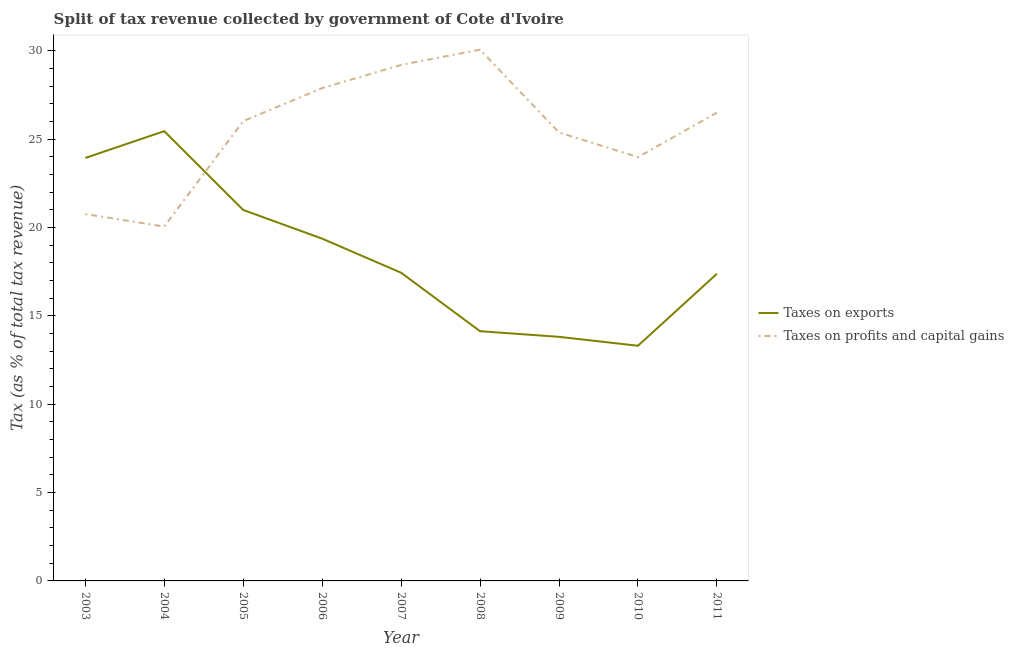Is the number of lines equal to the number of legend labels?
Ensure brevity in your answer.  Yes. What is the percentage of revenue obtained from taxes on exports in 2003?
Offer a terse response. 23.94. Across all years, what is the maximum percentage of revenue obtained from taxes on profits and capital gains?
Provide a succinct answer. 30.07. Across all years, what is the minimum percentage of revenue obtained from taxes on profits and capital gains?
Offer a very short reply. 20.06. In which year was the percentage of revenue obtained from taxes on exports minimum?
Provide a short and direct response. 2010. What is the total percentage of revenue obtained from taxes on exports in the graph?
Give a very brief answer. 165.85. What is the difference between the percentage of revenue obtained from taxes on exports in 2003 and that in 2010?
Offer a terse response. 10.63. What is the difference between the percentage of revenue obtained from taxes on profits and capital gains in 2005 and the percentage of revenue obtained from taxes on exports in 2010?
Make the answer very short. 12.71. What is the average percentage of revenue obtained from taxes on exports per year?
Your response must be concise. 18.43. In the year 2009, what is the difference between the percentage of revenue obtained from taxes on profits and capital gains and percentage of revenue obtained from taxes on exports?
Offer a terse response. 11.56. What is the ratio of the percentage of revenue obtained from taxes on profits and capital gains in 2005 to that in 2007?
Your answer should be very brief. 0.89. Is the difference between the percentage of revenue obtained from taxes on exports in 2005 and 2010 greater than the difference between the percentage of revenue obtained from taxes on profits and capital gains in 2005 and 2010?
Your answer should be very brief. Yes. What is the difference between the highest and the second highest percentage of revenue obtained from taxes on exports?
Make the answer very short. 1.52. What is the difference between the highest and the lowest percentage of revenue obtained from taxes on profits and capital gains?
Ensure brevity in your answer.  10.01. Is the sum of the percentage of revenue obtained from taxes on profits and capital gains in 2004 and 2011 greater than the maximum percentage of revenue obtained from taxes on exports across all years?
Your response must be concise. Yes. Does the percentage of revenue obtained from taxes on profits and capital gains monotonically increase over the years?
Provide a succinct answer. No. Is the percentage of revenue obtained from taxes on exports strictly greater than the percentage of revenue obtained from taxes on profits and capital gains over the years?
Ensure brevity in your answer.  No. How many years are there in the graph?
Your answer should be very brief. 9. Are the values on the major ticks of Y-axis written in scientific E-notation?
Provide a short and direct response. No. Does the graph contain any zero values?
Provide a succinct answer. No. Does the graph contain grids?
Give a very brief answer. No. Where does the legend appear in the graph?
Offer a terse response. Center right. How are the legend labels stacked?
Keep it short and to the point. Vertical. What is the title of the graph?
Your answer should be very brief. Split of tax revenue collected by government of Cote d'Ivoire. What is the label or title of the Y-axis?
Give a very brief answer. Tax (as % of total tax revenue). What is the Tax (as % of total tax revenue) of Taxes on exports in 2003?
Offer a very short reply. 23.94. What is the Tax (as % of total tax revenue) of Taxes on profits and capital gains in 2003?
Give a very brief answer. 20.76. What is the Tax (as % of total tax revenue) of Taxes on exports in 2004?
Keep it short and to the point. 25.46. What is the Tax (as % of total tax revenue) in Taxes on profits and capital gains in 2004?
Your response must be concise. 20.06. What is the Tax (as % of total tax revenue) in Taxes on exports in 2005?
Make the answer very short. 21. What is the Tax (as % of total tax revenue) in Taxes on profits and capital gains in 2005?
Offer a very short reply. 26.02. What is the Tax (as % of total tax revenue) of Taxes on exports in 2006?
Ensure brevity in your answer.  19.37. What is the Tax (as % of total tax revenue) of Taxes on profits and capital gains in 2006?
Give a very brief answer. 27.89. What is the Tax (as % of total tax revenue) of Taxes on exports in 2007?
Make the answer very short. 17.44. What is the Tax (as % of total tax revenue) of Taxes on profits and capital gains in 2007?
Make the answer very short. 29.21. What is the Tax (as % of total tax revenue) in Taxes on exports in 2008?
Provide a short and direct response. 14.13. What is the Tax (as % of total tax revenue) in Taxes on profits and capital gains in 2008?
Give a very brief answer. 30.07. What is the Tax (as % of total tax revenue) in Taxes on exports in 2009?
Offer a terse response. 13.81. What is the Tax (as % of total tax revenue) in Taxes on profits and capital gains in 2009?
Your answer should be very brief. 25.38. What is the Tax (as % of total tax revenue) in Taxes on exports in 2010?
Give a very brief answer. 13.31. What is the Tax (as % of total tax revenue) of Taxes on profits and capital gains in 2010?
Your response must be concise. 23.99. What is the Tax (as % of total tax revenue) of Taxes on exports in 2011?
Provide a short and direct response. 17.38. What is the Tax (as % of total tax revenue) of Taxes on profits and capital gains in 2011?
Make the answer very short. 26.5. Across all years, what is the maximum Tax (as % of total tax revenue) in Taxes on exports?
Give a very brief answer. 25.46. Across all years, what is the maximum Tax (as % of total tax revenue) of Taxes on profits and capital gains?
Give a very brief answer. 30.07. Across all years, what is the minimum Tax (as % of total tax revenue) of Taxes on exports?
Offer a terse response. 13.31. Across all years, what is the minimum Tax (as % of total tax revenue) in Taxes on profits and capital gains?
Your response must be concise. 20.06. What is the total Tax (as % of total tax revenue) of Taxes on exports in the graph?
Your response must be concise. 165.85. What is the total Tax (as % of total tax revenue) in Taxes on profits and capital gains in the graph?
Your answer should be compact. 229.88. What is the difference between the Tax (as % of total tax revenue) of Taxes on exports in 2003 and that in 2004?
Keep it short and to the point. -1.52. What is the difference between the Tax (as % of total tax revenue) of Taxes on profits and capital gains in 2003 and that in 2004?
Keep it short and to the point. 0.7. What is the difference between the Tax (as % of total tax revenue) in Taxes on exports in 2003 and that in 2005?
Provide a succinct answer. 2.94. What is the difference between the Tax (as % of total tax revenue) of Taxes on profits and capital gains in 2003 and that in 2005?
Provide a succinct answer. -5.26. What is the difference between the Tax (as % of total tax revenue) in Taxes on exports in 2003 and that in 2006?
Make the answer very short. 4.57. What is the difference between the Tax (as % of total tax revenue) of Taxes on profits and capital gains in 2003 and that in 2006?
Offer a terse response. -7.13. What is the difference between the Tax (as % of total tax revenue) in Taxes on exports in 2003 and that in 2007?
Make the answer very short. 6.5. What is the difference between the Tax (as % of total tax revenue) of Taxes on profits and capital gains in 2003 and that in 2007?
Your answer should be very brief. -8.44. What is the difference between the Tax (as % of total tax revenue) in Taxes on exports in 2003 and that in 2008?
Your answer should be very brief. 9.81. What is the difference between the Tax (as % of total tax revenue) in Taxes on profits and capital gains in 2003 and that in 2008?
Provide a succinct answer. -9.3. What is the difference between the Tax (as % of total tax revenue) of Taxes on exports in 2003 and that in 2009?
Provide a succinct answer. 10.12. What is the difference between the Tax (as % of total tax revenue) of Taxes on profits and capital gains in 2003 and that in 2009?
Your answer should be very brief. -4.62. What is the difference between the Tax (as % of total tax revenue) in Taxes on exports in 2003 and that in 2010?
Give a very brief answer. 10.63. What is the difference between the Tax (as % of total tax revenue) in Taxes on profits and capital gains in 2003 and that in 2010?
Make the answer very short. -3.22. What is the difference between the Tax (as % of total tax revenue) of Taxes on exports in 2003 and that in 2011?
Offer a very short reply. 6.56. What is the difference between the Tax (as % of total tax revenue) of Taxes on profits and capital gains in 2003 and that in 2011?
Offer a terse response. -5.74. What is the difference between the Tax (as % of total tax revenue) in Taxes on exports in 2004 and that in 2005?
Provide a short and direct response. 4.46. What is the difference between the Tax (as % of total tax revenue) of Taxes on profits and capital gains in 2004 and that in 2005?
Your answer should be compact. -5.96. What is the difference between the Tax (as % of total tax revenue) in Taxes on exports in 2004 and that in 2006?
Make the answer very short. 6.08. What is the difference between the Tax (as % of total tax revenue) in Taxes on profits and capital gains in 2004 and that in 2006?
Offer a very short reply. -7.83. What is the difference between the Tax (as % of total tax revenue) of Taxes on exports in 2004 and that in 2007?
Make the answer very short. 8.01. What is the difference between the Tax (as % of total tax revenue) of Taxes on profits and capital gains in 2004 and that in 2007?
Offer a very short reply. -9.15. What is the difference between the Tax (as % of total tax revenue) in Taxes on exports in 2004 and that in 2008?
Provide a succinct answer. 11.32. What is the difference between the Tax (as % of total tax revenue) of Taxes on profits and capital gains in 2004 and that in 2008?
Give a very brief answer. -10.01. What is the difference between the Tax (as % of total tax revenue) in Taxes on exports in 2004 and that in 2009?
Provide a short and direct response. 11.64. What is the difference between the Tax (as % of total tax revenue) in Taxes on profits and capital gains in 2004 and that in 2009?
Your response must be concise. -5.32. What is the difference between the Tax (as % of total tax revenue) of Taxes on exports in 2004 and that in 2010?
Your answer should be very brief. 12.15. What is the difference between the Tax (as % of total tax revenue) in Taxes on profits and capital gains in 2004 and that in 2010?
Give a very brief answer. -3.93. What is the difference between the Tax (as % of total tax revenue) in Taxes on exports in 2004 and that in 2011?
Ensure brevity in your answer.  8.07. What is the difference between the Tax (as % of total tax revenue) in Taxes on profits and capital gains in 2004 and that in 2011?
Give a very brief answer. -6.45. What is the difference between the Tax (as % of total tax revenue) of Taxes on exports in 2005 and that in 2006?
Offer a very short reply. 1.62. What is the difference between the Tax (as % of total tax revenue) in Taxes on profits and capital gains in 2005 and that in 2006?
Offer a very short reply. -1.87. What is the difference between the Tax (as % of total tax revenue) in Taxes on exports in 2005 and that in 2007?
Ensure brevity in your answer.  3.55. What is the difference between the Tax (as % of total tax revenue) in Taxes on profits and capital gains in 2005 and that in 2007?
Give a very brief answer. -3.18. What is the difference between the Tax (as % of total tax revenue) in Taxes on exports in 2005 and that in 2008?
Provide a succinct answer. 6.86. What is the difference between the Tax (as % of total tax revenue) in Taxes on profits and capital gains in 2005 and that in 2008?
Offer a very short reply. -4.04. What is the difference between the Tax (as % of total tax revenue) of Taxes on exports in 2005 and that in 2009?
Ensure brevity in your answer.  7.18. What is the difference between the Tax (as % of total tax revenue) in Taxes on profits and capital gains in 2005 and that in 2009?
Your answer should be compact. 0.64. What is the difference between the Tax (as % of total tax revenue) of Taxes on exports in 2005 and that in 2010?
Make the answer very short. 7.69. What is the difference between the Tax (as % of total tax revenue) of Taxes on profits and capital gains in 2005 and that in 2010?
Provide a succinct answer. 2.04. What is the difference between the Tax (as % of total tax revenue) in Taxes on exports in 2005 and that in 2011?
Offer a very short reply. 3.61. What is the difference between the Tax (as % of total tax revenue) of Taxes on profits and capital gains in 2005 and that in 2011?
Your answer should be compact. -0.48. What is the difference between the Tax (as % of total tax revenue) in Taxes on exports in 2006 and that in 2007?
Your answer should be very brief. 1.93. What is the difference between the Tax (as % of total tax revenue) of Taxes on profits and capital gains in 2006 and that in 2007?
Provide a succinct answer. -1.31. What is the difference between the Tax (as % of total tax revenue) of Taxes on exports in 2006 and that in 2008?
Offer a very short reply. 5.24. What is the difference between the Tax (as % of total tax revenue) in Taxes on profits and capital gains in 2006 and that in 2008?
Your answer should be very brief. -2.18. What is the difference between the Tax (as % of total tax revenue) of Taxes on exports in 2006 and that in 2009?
Keep it short and to the point. 5.56. What is the difference between the Tax (as % of total tax revenue) in Taxes on profits and capital gains in 2006 and that in 2009?
Your response must be concise. 2.51. What is the difference between the Tax (as % of total tax revenue) in Taxes on exports in 2006 and that in 2010?
Offer a very short reply. 6.06. What is the difference between the Tax (as % of total tax revenue) in Taxes on profits and capital gains in 2006 and that in 2010?
Your answer should be compact. 3.91. What is the difference between the Tax (as % of total tax revenue) in Taxes on exports in 2006 and that in 2011?
Ensure brevity in your answer.  1.99. What is the difference between the Tax (as % of total tax revenue) in Taxes on profits and capital gains in 2006 and that in 2011?
Offer a terse response. 1.39. What is the difference between the Tax (as % of total tax revenue) in Taxes on exports in 2007 and that in 2008?
Keep it short and to the point. 3.31. What is the difference between the Tax (as % of total tax revenue) of Taxes on profits and capital gains in 2007 and that in 2008?
Your answer should be compact. -0.86. What is the difference between the Tax (as % of total tax revenue) in Taxes on exports in 2007 and that in 2009?
Your answer should be compact. 3.63. What is the difference between the Tax (as % of total tax revenue) in Taxes on profits and capital gains in 2007 and that in 2009?
Provide a succinct answer. 3.83. What is the difference between the Tax (as % of total tax revenue) in Taxes on exports in 2007 and that in 2010?
Your response must be concise. 4.13. What is the difference between the Tax (as % of total tax revenue) in Taxes on profits and capital gains in 2007 and that in 2010?
Offer a very short reply. 5.22. What is the difference between the Tax (as % of total tax revenue) of Taxes on exports in 2007 and that in 2011?
Make the answer very short. 0.06. What is the difference between the Tax (as % of total tax revenue) of Taxes on profits and capital gains in 2007 and that in 2011?
Ensure brevity in your answer.  2.7. What is the difference between the Tax (as % of total tax revenue) in Taxes on exports in 2008 and that in 2009?
Offer a terse response. 0.32. What is the difference between the Tax (as % of total tax revenue) of Taxes on profits and capital gains in 2008 and that in 2009?
Offer a very short reply. 4.69. What is the difference between the Tax (as % of total tax revenue) of Taxes on exports in 2008 and that in 2010?
Provide a succinct answer. 0.82. What is the difference between the Tax (as % of total tax revenue) in Taxes on profits and capital gains in 2008 and that in 2010?
Give a very brief answer. 6.08. What is the difference between the Tax (as % of total tax revenue) in Taxes on exports in 2008 and that in 2011?
Keep it short and to the point. -3.25. What is the difference between the Tax (as % of total tax revenue) in Taxes on profits and capital gains in 2008 and that in 2011?
Offer a terse response. 3.56. What is the difference between the Tax (as % of total tax revenue) of Taxes on exports in 2009 and that in 2010?
Provide a short and direct response. 0.5. What is the difference between the Tax (as % of total tax revenue) in Taxes on profits and capital gains in 2009 and that in 2010?
Make the answer very short. 1.39. What is the difference between the Tax (as % of total tax revenue) in Taxes on exports in 2009 and that in 2011?
Provide a succinct answer. -3.57. What is the difference between the Tax (as % of total tax revenue) of Taxes on profits and capital gains in 2009 and that in 2011?
Ensure brevity in your answer.  -1.12. What is the difference between the Tax (as % of total tax revenue) of Taxes on exports in 2010 and that in 2011?
Ensure brevity in your answer.  -4.07. What is the difference between the Tax (as % of total tax revenue) of Taxes on profits and capital gains in 2010 and that in 2011?
Keep it short and to the point. -2.52. What is the difference between the Tax (as % of total tax revenue) of Taxes on exports in 2003 and the Tax (as % of total tax revenue) of Taxes on profits and capital gains in 2004?
Offer a very short reply. 3.88. What is the difference between the Tax (as % of total tax revenue) in Taxes on exports in 2003 and the Tax (as % of total tax revenue) in Taxes on profits and capital gains in 2005?
Give a very brief answer. -2.08. What is the difference between the Tax (as % of total tax revenue) in Taxes on exports in 2003 and the Tax (as % of total tax revenue) in Taxes on profits and capital gains in 2006?
Your response must be concise. -3.95. What is the difference between the Tax (as % of total tax revenue) of Taxes on exports in 2003 and the Tax (as % of total tax revenue) of Taxes on profits and capital gains in 2007?
Provide a succinct answer. -5.27. What is the difference between the Tax (as % of total tax revenue) of Taxes on exports in 2003 and the Tax (as % of total tax revenue) of Taxes on profits and capital gains in 2008?
Provide a succinct answer. -6.13. What is the difference between the Tax (as % of total tax revenue) of Taxes on exports in 2003 and the Tax (as % of total tax revenue) of Taxes on profits and capital gains in 2009?
Make the answer very short. -1.44. What is the difference between the Tax (as % of total tax revenue) of Taxes on exports in 2003 and the Tax (as % of total tax revenue) of Taxes on profits and capital gains in 2010?
Provide a succinct answer. -0.05. What is the difference between the Tax (as % of total tax revenue) in Taxes on exports in 2003 and the Tax (as % of total tax revenue) in Taxes on profits and capital gains in 2011?
Your answer should be compact. -2.56. What is the difference between the Tax (as % of total tax revenue) in Taxes on exports in 2004 and the Tax (as % of total tax revenue) in Taxes on profits and capital gains in 2005?
Your answer should be very brief. -0.57. What is the difference between the Tax (as % of total tax revenue) in Taxes on exports in 2004 and the Tax (as % of total tax revenue) in Taxes on profits and capital gains in 2006?
Provide a succinct answer. -2.44. What is the difference between the Tax (as % of total tax revenue) of Taxes on exports in 2004 and the Tax (as % of total tax revenue) of Taxes on profits and capital gains in 2007?
Provide a short and direct response. -3.75. What is the difference between the Tax (as % of total tax revenue) in Taxes on exports in 2004 and the Tax (as % of total tax revenue) in Taxes on profits and capital gains in 2008?
Offer a very short reply. -4.61. What is the difference between the Tax (as % of total tax revenue) in Taxes on exports in 2004 and the Tax (as % of total tax revenue) in Taxes on profits and capital gains in 2009?
Your answer should be compact. 0.08. What is the difference between the Tax (as % of total tax revenue) in Taxes on exports in 2004 and the Tax (as % of total tax revenue) in Taxes on profits and capital gains in 2010?
Give a very brief answer. 1.47. What is the difference between the Tax (as % of total tax revenue) in Taxes on exports in 2004 and the Tax (as % of total tax revenue) in Taxes on profits and capital gains in 2011?
Offer a very short reply. -1.05. What is the difference between the Tax (as % of total tax revenue) in Taxes on exports in 2005 and the Tax (as % of total tax revenue) in Taxes on profits and capital gains in 2006?
Your response must be concise. -6.9. What is the difference between the Tax (as % of total tax revenue) in Taxes on exports in 2005 and the Tax (as % of total tax revenue) in Taxes on profits and capital gains in 2007?
Offer a terse response. -8.21. What is the difference between the Tax (as % of total tax revenue) in Taxes on exports in 2005 and the Tax (as % of total tax revenue) in Taxes on profits and capital gains in 2008?
Your answer should be very brief. -9.07. What is the difference between the Tax (as % of total tax revenue) in Taxes on exports in 2005 and the Tax (as % of total tax revenue) in Taxes on profits and capital gains in 2009?
Ensure brevity in your answer.  -4.38. What is the difference between the Tax (as % of total tax revenue) of Taxes on exports in 2005 and the Tax (as % of total tax revenue) of Taxes on profits and capital gains in 2010?
Your answer should be compact. -2.99. What is the difference between the Tax (as % of total tax revenue) of Taxes on exports in 2005 and the Tax (as % of total tax revenue) of Taxes on profits and capital gains in 2011?
Offer a very short reply. -5.51. What is the difference between the Tax (as % of total tax revenue) of Taxes on exports in 2006 and the Tax (as % of total tax revenue) of Taxes on profits and capital gains in 2007?
Make the answer very short. -9.83. What is the difference between the Tax (as % of total tax revenue) in Taxes on exports in 2006 and the Tax (as % of total tax revenue) in Taxes on profits and capital gains in 2008?
Provide a short and direct response. -10.7. What is the difference between the Tax (as % of total tax revenue) of Taxes on exports in 2006 and the Tax (as % of total tax revenue) of Taxes on profits and capital gains in 2009?
Make the answer very short. -6.01. What is the difference between the Tax (as % of total tax revenue) of Taxes on exports in 2006 and the Tax (as % of total tax revenue) of Taxes on profits and capital gains in 2010?
Offer a terse response. -4.61. What is the difference between the Tax (as % of total tax revenue) of Taxes on exports in 2006 and the Tax (as % of total tax revenue) of Taxes on profits and capital gains in 2011?
Your answer should be very brief. -7.13. What is the difference between the Tax (as % of total tax revenue) of Taxes on exports in 2007 and the Tax (as % of total tax revenue) of Taxes on profits and capital gains in 2008?
Your answer should be compact. -12.62. What is the difference between the Tax (as % of total tax revenue) of Taxes on exports in 2007 and the Tax (as % of total tax revenue) of Taxes on profits and capital gains in 2009?
Offer a very short reply. -7.94. What is the difference between the Tax (as % of total tax revenue) in Taxes on exports in 2007 and the Tax (as % of total tax revenue) in Taxes on profits and capital gains in 2010?
Offer a terse response. -6.54. What is the difference between the Tax (as % of total tax revenue) of Taxes on exports in 2007 and the Tax (as % of total tax revenue) of Taxes on profits and capital gains in 2011?
Keep it short and to the point. -9.06. What is the difference between the Tax (as % of total tax revenue) in Taxes on exports in 2008 and the Tax (as % of total tax revenue) in Taxes on profits and capital gains in 2009?
Keep it short and to the point. -11.25. What is the difference between the Tax (as % of total tax revenue) in Taxes on exports in 2008 and the Tax (as % of total tax revenue) in Taxes on profits and capital gains in 2010?
Provide a short and direct response. -9.85. What is the difference between the Tax (as % of total tax revenue) in Taxes on exports in 2008 and the Tax (as % of total tax revenue) in Taxes on profits and capital gains in 2011?
Your answer should be very brief. -12.37. What is the difference between the Tax (as % of total tax revenue) of Taxes on exports in 2009 and the Tax (as % of total tax revenue) of Taxes on profits and capital gains in 2010?
Provide a succinct answer. -10.17. What is the difference between the Tax (as % of total tax revenue) in Taxes on exports in 2009 and the Tax (as % of total tax revenue) in Taxes on profits and capital gains in 2011?
Your response must be concise. -12.69. What is the difference between the Tax (as % of total tax revenue) of Taxes on exports in 2010 and the Tax (as % of total tax revenue) of Taxes on profits and capital gains in 2011?
Give a very brief answer. -13.19. What is the average Tax (as % of total tax revenue) of Taxes on exports per year?
Your answer should be very brief. 18.43. What is the average Tax (as % of total tax revenue) in Taxes on profits and capital gains per year?
Ensure brevity in your answer.  25.54. In the year 2003, what is the difference between the Tax (as % of total tax revenue) of Taxes on exports and Tax (as % of total tax revenue) of Taxes on profits and capital gains?
Offer a terse response. 3.18. In the year 2004, what is the difference between the Tax (as % of total tax revenue) of Taxes on exports and Tax (as % of total tax revenue) of Taxes on profits and capital gains?
Your answer should be compact. 5.4. In the year 2005, what is the difference between the Tax (as % of total tax revenue) in Taxes on exports and Tax (as % of total tax revenue) in Taxes on profits and capital gains?
Your response must be concise. -5.03. In the year 2006, what is the difference between the Tax (as % of total tax revenue) of Taxes on exports and Tax (as % of total tax revenue) of Taxes on profits and capital gains?
Keep it short and to the point. -8.52. In the year 2007, what is the difference between the Tax (as % of total tax revenue) of Taxes on exports and Tax (as % of total tax revenue) of Taxes on profits and capital gains?
Give a very brief answer. -11.76. In the year 2008, what is the difference between the Tax (as % of total tax revenue) of Taxes on exports and Tax (as % of total tax revenue) of Taxes on profits and capital gains?
Offer a very short reply. -15.93. In the year 2009, what is the difference between the Tax (as % of total tax revenue) in Taxes on exports and Tax (as % of total tax revenue) in Taxes on profits and capital gains?
Offer a very short reply. -11.56. In the year 2010, what is the difference between the Tax (as % of total tax revenue) in Taxes on exports and Tax (as % of total tax revenue) in Taxes on profits and capital gains?
Your answer should be very brief. -10.68. In the year 2011, what is the difference between the Tax (as % of total tax revenue) in Taxes on exports and Tax (as % of total tax revenue) in Taxes on profits and capital gains?
Your answer should be compact. -9.12. What is the ratio of the Tax (as % of total tax revenue) in Taxes on exports in 2003 to that in 2004?
Provide a short and direct response. 0.94. What is the ratio of the Tax (as % of total tax revenue) of Taxes on profits and capital gains in 2003 to that in 2004?
Offer a terse response. 1.04. What is the ratio of the Tax (as % of total tax revenue) in Taxes on exports in 2003 to that in 2005?
Your answer should be very brief. 1.14. What is the ratio of the Tax (as % of total tax revenue) of Taxes on profits and capital gains in 2003 to that in 2005?
Your answer should be compact. 0.8. What is the ratio of the Tax (as % of total tax revenue) of Taxes on exports in 2003 to that in 2006?
Make the answer very short. 1.24. What is the ratio of the Tax (as % of total tax revenue) of Taxes on profits and capital gains in 2003 to that in 2006?
Your answer should be compact. 0.74. What is the ratio of the Tax (as % of total tax revenue) in Taxes on exports in 2003 to that in 2007?
Your response must be concise. 1.37. What is the ratio of the Tax (as % of total tax revenue) of Taxes on profits and capital gains in 2003 to that in 2007?
Offer a very short reply. 0.71. What is the ratio of the Tax (as % of total tax revenue) of Taxes on exports in 2003 to that in 2008?
Your answer should be very brief. 1.69. What is the ratio of the Tax (as % of total tax revenue) in Taxes on profits and capital gains in 2003 to that in 2008?
Make the answer very short. 0.69. What is the ratio of the Tax (as % of total tax revenue) in Taxes on exports in 2003 to that in 2009?
Your answer should be compact. 1.73. What is the ratio of the Tax (as % of total tax revenue) of Taxes on profits and capital gains in 2003 to that in 2009?
Make the answer very short. 0.82. What is the ratio of the Tax (as % of total tax revenue) in Taxes on exports in 2003 to that in 2010?
Your response must be concise. 1.8. What is the ratio of the Tax (as % of total tax revenue) in Taxes on profits and capital gains in 2003 to that in 2010?
Give a very brief answer. 0.87. What is the ratio of the Tax (as % of total tax revenue) in Taxes on exports in 2003 to that in 2011?
Make the answer very short. 1.38. What is the ratio of the Tax (as % of total tax revenue) of Taxes on profits and capital gains in 2003 to that in 2011?
Make the answer very short. 0.78. What is the ratio of the Tax (as % of total tax revenue) in Taxes on exports in 2004 to that in 2005?
Ensure brevity in your answer.  1.21. What is the ratio of the Tax (as % of total tax revenue) in Taxes on profits and capital gains in 2004 to that in 2005?
Offer a terse response. 0.77. What is the ratio of the Tax (as % of total tax revenue) of Taxes on exports in 2004 to that in 2006?
Ensure brevity in your answer.  1.31. What is the ratio of the Tax (as % of total tax revenue) of Taxes on profits and capital gains in 2004 to that in 2006?
Ensure brevity in your answer.  0.72. What is the ratio of the Tax (as % of total tax revenue) of Taxes on exports in 2004 to that in 2007?
Offer a terse response. 1.46. What is the ratio of the Tax (as % of total tax revenue) of Taxes on profits and capital gains in 2004 to that in 2007?
Provide a succinct answer. 0.69. What is the ratio of the Tax (as % of total tax revenue) in Taxes on exports in 2004 to that in 2008?
Provide a succinct answer. 1.8. What is the ratio of the Tax (as % of total tax revenue) of Taxes on profits and capital gains in 2004 to that in 2008?
Offer a terse response. 0.67. What is the ratio of the Tax (as % of total tax revenue) in Taxes on exports in 2004 to that in 2009?
Your answer should be compact. 1.84. What is the ratio of the Tax (as % of total tax revenue) in Taxes on profits and capital gains in 2004 to that in 2009?
Make the answer very short. 0.79. What is the ratio of the Tax (as % of total tax revenue) in Taxes on exports in 2004 to that in 2010?
Ensure brevity in your answer.  1.91. What is the ratio of the Tax (as % of total tax revenue) in Taxes on profits and capital gains in 2004 to that in 2010?
Offer a very short reply. 0.84. What is the ratio of the Tax (as % of total tax revenue) of Taxes on exports in 2004 to that in 2011?
Your answer should be very brief. 1.46. What is the ratio of the Tax (as % of total tax revenue) in Taxes on profits and capital gains in 2004 to that in 2011?
Your response must be concise. 0.76. What is the ratio of the Tax (as % of total tax revenue) of Taxes on exports in 2005 to that in 2006?
Provide a short and direct response. 1.08. What is the ratio of the Tax (as % of total tax revenue) in Taxes on profits and capital gains in 2005 to that in 2006?
Offer a terse response. 0.93. What is the ratio of the Tax (as % of total tax revenue) of Taxes on exports in 2005 to that in 2007?
Offer a terse response. 1.2. What is the ratio of the Tax (as % of total tax revenue) in Taxes on profits and capital gains in 2005 to that in 2007?
Provide a short and direct response. 0.89. What is the ratio of the Tax (as % of total tax revenue) in Taxes on exports in 2005 to that in 2008?
Offer a very short reply. 1.49. What is the ratio of the Tax (as % of total tax revenue) in Taxes on profits and capital gains in 2005 to that in 2008?
Ensure brevity in your answer.  0.87. What is the ratio of the Tax (as % of total tax revenue) in Taxes on exports in 2005 to that in 2009?
Keep it short and to the point. 1.52. What is the ratio of the Tax (as % of total tax revenue) in Taxes on profits and capital gains in 2005 to that in 2009?
Make the answer very short. 1.03. What is the ratio of the Tax (as % of total tax revenue) in Taxes on exports in 2005 to that in 2010?
Offer a very short reply. 1.58. What is the ratio of the Tax (as % of total tax revenue) in Taxes on profits and capital gains in 2005 to that in 2010?
Your answer should be very brief. 1.08. What is the ratio of the Tax (as % of total tax revenue) in Taxes on exports in 2005 to that in 2011?
Your answer should be compact. 1.21. What is the ratio of the Tax (as % of total tax revenue) of Taxes on profits and capital gains in 2005 to that in 2011?
Offer a terse response. 0.98. What is the ratio of the Tax (as % of total tax revenue) of Taxes on exports in 2006 to that in 2007?
Ensure brevity in your answer.  1.11. What is the ratio of the Tax (as % of total tax revenue) of Taxes on profits and capital gains in 2006 to that in 2007?
Provide a short and direct response. 0.95. What is the ratio of the Tax (as % of total tax revenue) in Taxes on exports in 2006 to that in 2008?
Give a very brief answer. 1.37. What is the ratio of the Tax (as % of total tax revenue) of Taxes on profits and capital gains in 2006 to that in 2008?
Keep it short and to the point. 0.93. What is the ratio of the Tax (as % of total tax revenue) of Taxes on exports in 2006 to that in 2009?
Give a very brief answer. 1.4. What is the ratio of the Tax (as % of total tax revenue) in Taxes on profits and capital gains in 2006 to that in 2009?
Give a very brief answer. 1.1. What is the ratio of the Tax (as % of total tax revenue) in Taxes on exports in 2006 to that in 2010?
Provide a succinct answer. 1.46. What is the ratio of the Tax (as % of total tax revenue) of Taxes on profits and capital gains in 2006 to that in 2010?
Give a very brief answer. 1.16. What is the ratio of the Tax (as % of total tax revenue) in Taxes on exports in 2006 to that in 2011?
Keep it short and to the point. 1.11. What is the ratio of the Tax (as % of total tax revenue) of Taxes on profits and capital gains in 2006 to that in 2011?
Provide a short and direct response. 1.05. What is the ratio of the Tax (as % of total tax revenue) in Taxes on exports in 2007 to that in 2008?
Keep it short and to the point. 1.23. What is the ratio of the Tax (as % of total tax revenue) of Taxes on profits and capital gains in 2007 to that in 2008?
Offer a very short reply. 0.97. What is the ratio of the Tax (as % of total tax revenue) in Taxes on exports in 2007 to that in 2009?
Provide a short and direct response. 1.26. What is the ratio of the Tax (as % of total tax revenue) in Taxes on profits and capital gains in 2007 to that in 2009?
Ensure brevity in your answer.  1.15. What is the ratio of the Tax (as % of total tax revenue) in Taxes on exports in 2007 to that in 2010?
Offer a very short reply. 1.31. What is the ratio of the Tax (as % of total tax revenue) in Taxes on profits and capital gains in 2007 to that in 2010?
Provide a succinct answer. 1.22. What is the ratio of the Tax (as % of total tax revenue) in Taxes on profits and capital gains in 2007 to that in 2011?
Offer a terse response. 1.1. What is the ratio of the Tax (as % of total tax revenue) of Taxes on exports in 2008 to that in 2009?
Your answer should be compact. 1.02. What is the ratio of the Tax (as % of total tax revenue) of Taxes on profits and capital gains in 2008 to that in 2009?
Offer a terse response. 1.18. What is the ratio of the Tax (as % of total tax revenue) of Taxes on exports in 2008 to that in 2010?
Offer a terse response. 1.06. What is the ratio of the Tax (as % of total tax revenue) of Taxes on profits and capital gains in 2008 to that in 2010?
Offer a terse response. 1.25. What is the ratio of the Tax (as % of total tax revenue) in Taxes on exports in 2008 to that in 2011?
Give a very brief answer. 0.81. What is the ratio of the Tax (as % of total tax revenue) of Taxes on profits and capital gains in 2008 to that in 2011?
Give a very brief answer. 1.13. What is the ratio of the Tax (as % of total tax revenue) in Taxes on exports in 2009 to that in 2010?
Give a very brief answer. 1.04. What is the ratio of the Tax (as % of total tax revenue) of Taxes on profits and capital gains in 2009 to that in 2010?
Offer a very short reply. 1.06. What is the ratio of the Tax (as % of total tax revenue) of Taxes on exports in 2009 to that in 2011?
Make the answer very short. 0.79. What is the ratio of the Tax (as % of total tax revenue) of Taxes on profits and capital gains in 2009 to that in 2011?
Provide a short and direct response. 0.96. What is the ratio of the Tax (as % of total tax revenue) in Taxes on exports in 2010 to that in 2011?
Make the answer very short. 0.77. What is the ratio of the Tax (as % of total tax revenue) of Taxes on profits and capital gains in 2010 to that in 2011?
Your response must be concise. 0.91. What is the difference between the highest and the second highest Tax (as % of total tax revenue) of Taxes on exports?
Provide a succinct answer. 1.52. What is the difference between the highest and the second highest Tax (as % of total tax revenue) of Taxes on profits and capital gains?
Your answer should be very brief. 0.86. What is the difference between the highest and the lowest Tax (as % of total tax revenue) in Taxes on exports?
Provide a succinct answer. 12.15. What is the difference between the highest and the lowest Tax (as % of total tax revenue) of Taxes on profits and capital gains?
Ensure brevity in your answer.  10.01. 